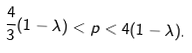Convert formula to latex. <formula><loc_0><loc_0><loc_500><loc_500>\frac { 4 } { 3 } ( 1 - \lambda ) < p < 4 ( 1 - \lambda ) .</formula> 